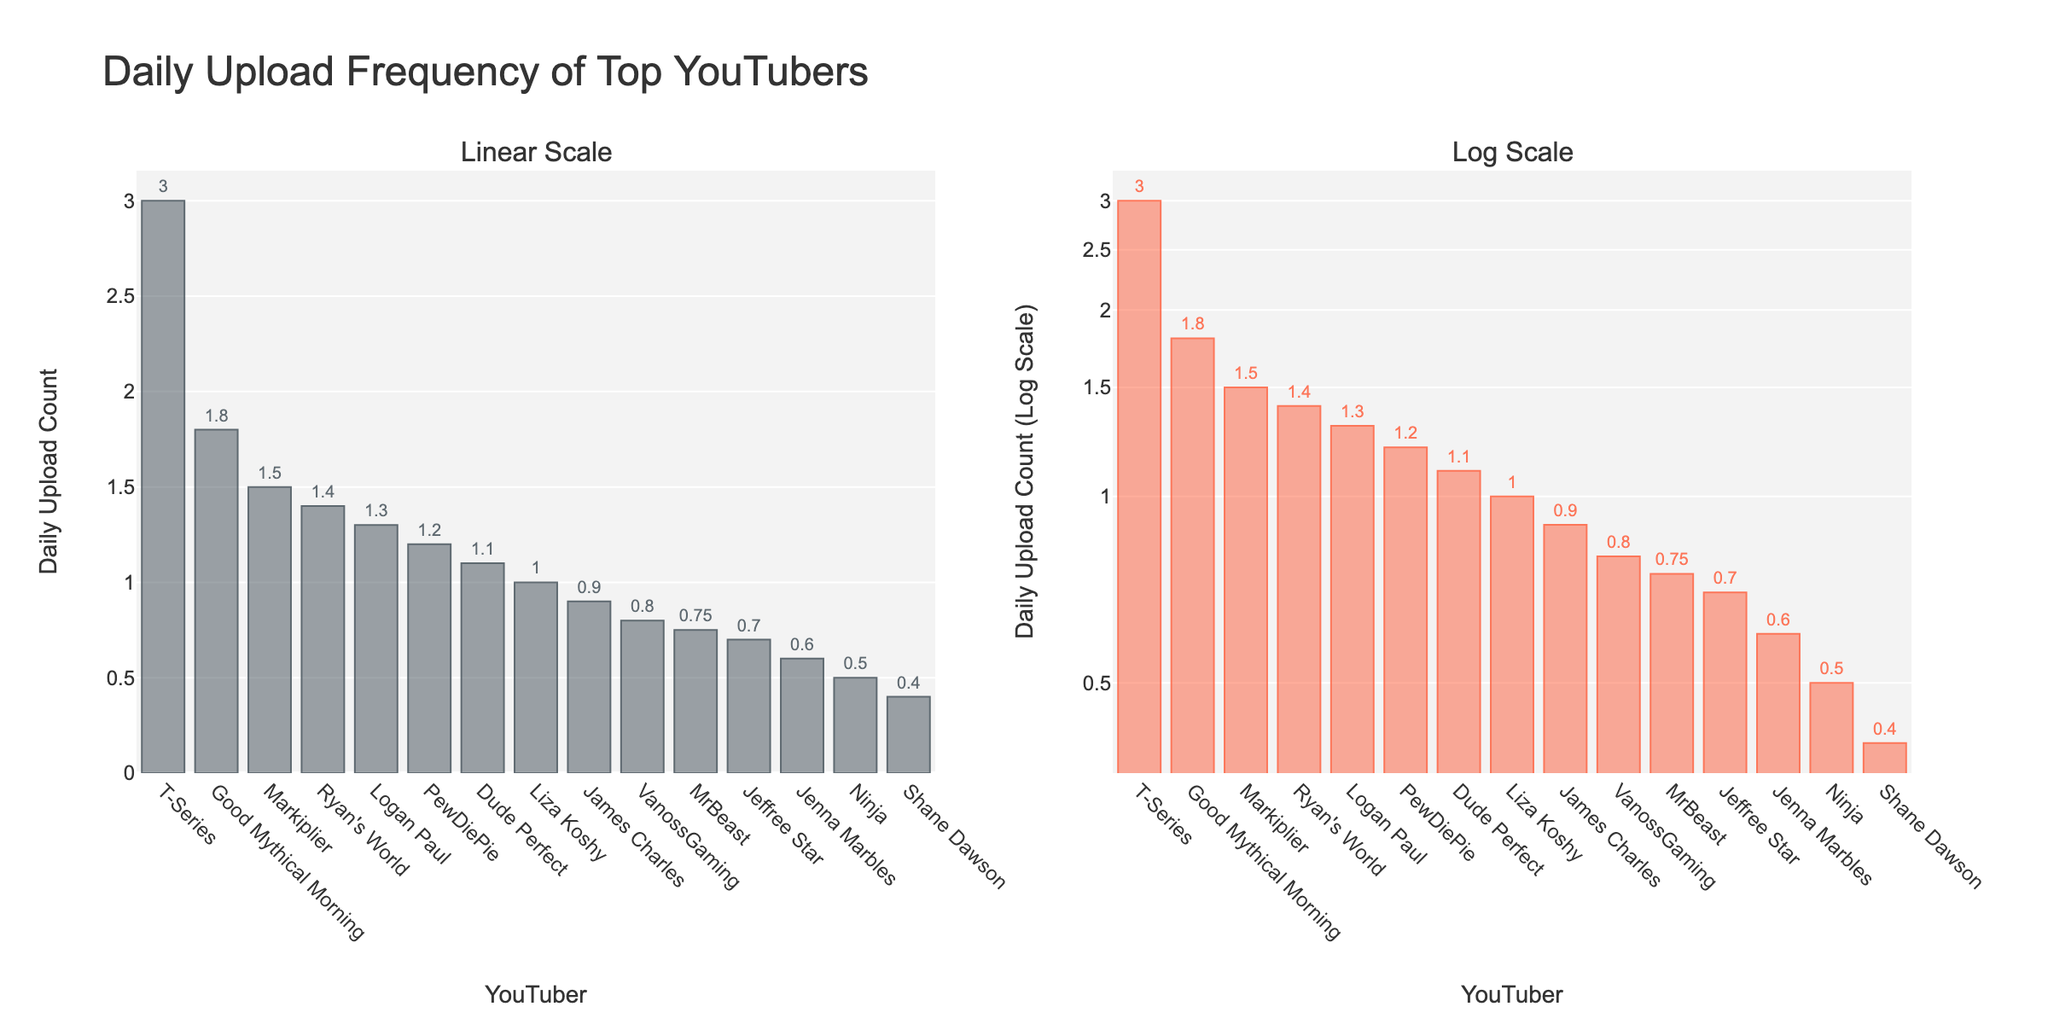What's the title of the figure? The title is displayed prominently at the top and it reads "Daily Upload Frequency of Top YouTubers"
Answer: Daily Upload Frequency of Top YouTubers How many YouTubers upload more than one video daily based on the linear scale plot? From the linear scale plot, you can see the bars reaching more than the value of 1 on the y-axis for PewDiePie, Markiplier, Dude Perfect, Logan Paul, T-Series, Ryan's World, and Good Mythical Morning
Answer: 7 Which YouTuber has the highest daily upload count? Both the linear and the log scale plots show T-Series with the tallest bar, indicating the highest daily upload count of 3
Answer: T-Series What's the daily upload count of MrBeast on both scales? By observing the bars corresponding to MrBeast, both scale plots show a daily upload count of 0.75 as labeled on the bars
Answer: 0.75 Which YouTuber uploads the least daily? Shane Dawson has the shortest bar in both linear and log scale plots, indicating a daily upload count of 0.4
Answer: Shane Dawson What is the difference in daily uploads between Ryan's World and Good Mythical Morning? From the linear scale plot, Ryan's World has a daily upload count of 1.4 while Good Mythical Morning has 1.8. The difference is 1.8 - 1.4 = 0.4
Answer: 0.4 How does the log scale plot help in viewing the upload counts? The log scale plot compresses the large differences, making it easier to see variations among the smaller values that might be compressed in the linear scale plot
Answer: Easier to view smaller variations What color represents the linear scale bars? The bars in the linear scale plot are in a dark bluish-grey color
Answer: Dark bluish-grey What is the slope style of the second (log scale) y-axis? The y-axis in the log scale plot shows exponential increments because it uses a logarithmic scale
Answer: Exponential increments How many YouTubers have a daily upload count between 0.5 and 1.0 inclusive? From the linear scale plot, MrBeast, Ninja, James Charles, Jenna Marbles, Jeffree Star, and VanossGaming fall within this range
Answer: 6 